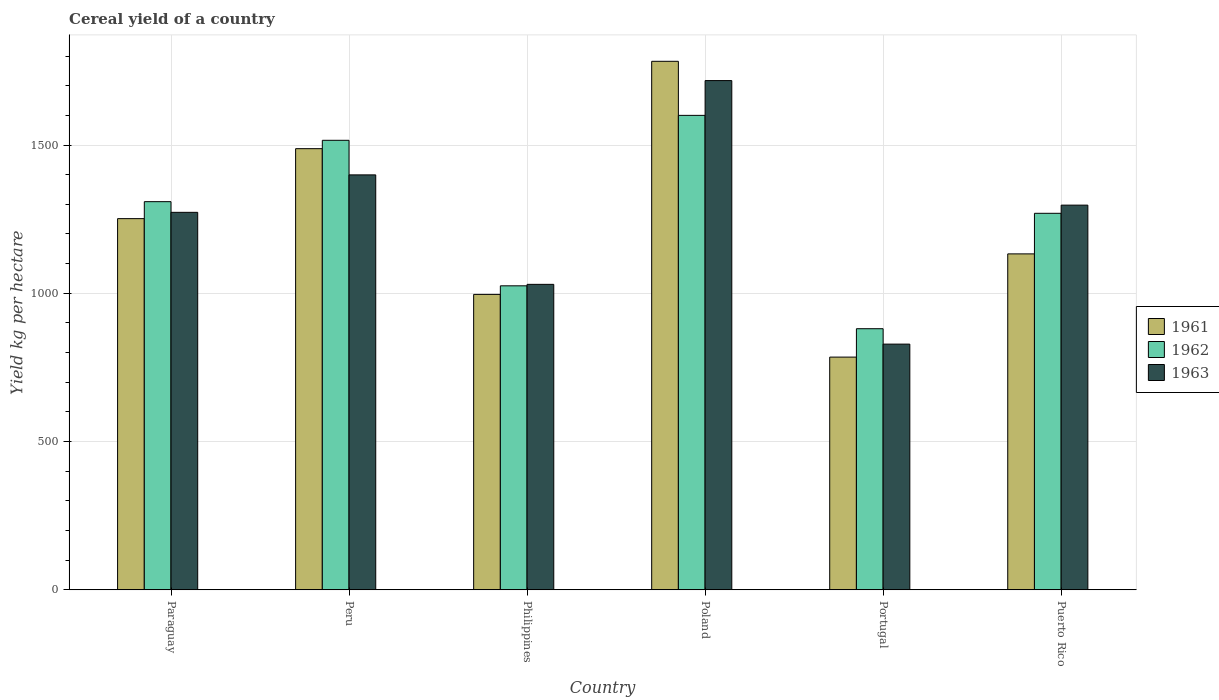How many different coloured bars are there?
Make the answer very short. 3. How many groups of bars are there?
Your response must be concise. 6. Are the number of bars per tick equal to the number of legend labels?
Provide a short and direct response. Yes. Are the number of bars on each tick of the X-axis equal?
Ensure brevity in your answer.  Yes. How many bars are there on the 1st tick from the left?
Offer a terse response. 3. What is the label of the 1st group of bars from the left?
Offer a terse response. Paraguay. In how many cases, is the number of bars for a given country not equal to the number of legend labels?
Make the answer very short. 0. What is the total cereal yield in 1961 in Paraguay?
Your answer should be compact. 1251.79. Across all countries, what is the maximum total cereal yield in 1963?
Offer a very short reply. 1717.34. Across all countries, what is the minimum total cereal yield in 1961?
Give a very brief answer. 784.84. In which country was the total cereal yield in 1962 minimum?
Your answer should be very brief. Portugal. What is the total total cereal yield in 1963 in the graph?
Offer a terse response. 7545.87. What is the difference between the total cereal yield in 1963 in Paraguay and that in Poland?
Your answer should be compact. -444.3. What is the difference between the total cereal yield in 1962 in Puerto Rico and the total cereal yield in 1961 in Poland?
Your answer should be compact. -512.57. What is the average total cereal yield in 1961 per country?
Offer a very short reply. 1239.33. What is the difference between the total cereal yield of/in 1961 and total cereal yield of/in 1962 in Portugal?
Offer a very short reply. -95.75. In how many countries, is the total cereal yield in 1961 greater than 1700 kg per hectare?
Make the answer very short. 1. What is the ratio of the total cereal yield in 1963 in Philippines to that in Poland?
Offer a terse response. 0.6. Is the total cereal yield in 1961 in Philippines less than that in Puerto Rico?
Your answer should be very brief. Yes. What is the difference between the highest and the second highest total cereal yield in 1962?
Offer a very short reply. 84.11. What is the difference between the highest and the lowest total cereal yield in 1962?
Make the answer very short. 719.47. In how many countries, is the total cereal yield in 1961 greater than the average total cereal yield in 1961 taken over all countries?
Your answer should be very brief. 3. Are all the bars in the graph horizontal?
Your response must be concise. No. How many countries are there in the graph?
Ensure brevity in your answer.  6. Are the values on the major ticks of Y-axis written in scientific E-notation?
Keep it short and to the point. No. Does the graph contain grids?
Offer a very short reply. Yes. How many legend labels are there?
Your response must be concise. 3. How are the legend labels stacked?
Your answer should be very brief. Vertical. What is the title of the graph?
Offer a very short reply. Cereal yield of a country. Does "2001" appear as one of the legend labels in the graph?
Your answer should be very brief. No. What is the label or title of the X-axis?
Make the answer very short. Country. What is the label or title of the Y-axis?
Your response must be concise. Yield kg per hectare. What is the Yield kg per hectare in 1961 in Paraguay?
Ensure brevity in your answer.  1251.79. What is the Yield kg per hectare of 1962 in Paraguay?
Your answer should be very brief. 1309.03. What is the Yield kg per hectare of 1963 in Paraguay?
Give a very brief answer. 1273.04. What is the Yield kg per hectare in 1961 in Peru?
Keep it short and to the point. 1487.76. What is the Yield kg per hectare in 1962 in Peru?
Provide a succinct answer. 1515.95. What is the Yield kg per hectare of 1963 in Peru?
Your response must be concise. 1399.36. What is the Yield kg per hectare in 1961 in Philippines?
Make the answer very short. 996.33. What is the Yield kg per hectare in 1962 in Philippines?
Keep it short and to the point. 1025.25. What is the Yield kg per hectare of 1963 in Philippines?
Give a very brief answer. 1030.2. What is the Yield kg per hectare of 1961 in Poland?
Your response must be concise. 1782.35. What is the Yield kg per hectare of 1962 in Poland?
Ensure brevity in your answer.  1600.06. What is the Yield kg per hectare of 1963 in Poland?
Offer a very short reply. 1717.34. What is the Yield kg per hectare of 1961 in Portugal?
Your answer should be compact. 784.84. What is the Yield kg per hectare in 1962 in Portugal?
Offer a terse response. 880.59. What is the Yield kg per hectare in 1963 in Portugal?
Provide a short and direct response. 828.63. What is the Yield kg per hectare in 1961 in Puerto Rico?
Offer a very short reply. 1132.94. What is the Yield kg per hectare of 1962 in Puerto Rico?
Provide a short and direct response. 1269.79. What is the Yield kg per hectare in 1963 in Puerto Rico?
Ensure brevity in your answer.  1297.3. Across all countries, what is the maximum Yield kg per hectare in 1961?
Offer a terse response. 1782.35. Across all countries, what is the maximum Yield kg per hectare in 1962?
Ensure brevity in your answer.  1600.06. Across all countries, what is the maximum Yield kg per hectare in 1963?
Your answer should be very brief. 1717.34. Across all countries, what is the minimum Yield kg per hectare in 1961?
Your answer should be compact. 784.84. Across all countries, what is the minimum Yield kg per hectare in 1962?
Offer a very short reply. 880.59. Across all countries, what is the minimum Yield kg per hectare in 1963?
Your answer should be very brief. 828.63. What is the total Yield kg per hectare of 1961 in the graph?
Keep it short and to the point. 7436. What is the total Yield kg per hectare of 1962 in the graph?
Offer a very short reply. 7600.67. What is the total Yield kg per hectare of 1963 in the graph?
Your response must be concise. 7545.87. What is the difference between the Yield kg per hectare in 1961 in Paraguay and that in Peru?
Keep it short and to the point. -235.96. What is the difference between the Yield kg per hectare in 1962 in Paraguay and that in Peru?
Offer a very short reply. -206.92. What is the difference between the Yield kg per hectare of 1963 in Paraguay and that in Peru?
Your answer should be compact. -126.32. What is the difference between the Yield kg per hectare of 1961 in Paraguay and that in Philippines?
Your answer should be very brief. 255.47. What is the difference between the Yield kg per hectare in 1962 in Paraguay and that in Philippines?
Your answer should be compact. 283.78. What is the difference between the Yield kg per hectare of 1963 in Paraguay and that in Philippines?
Make the answer very short. 242.84. What is the difference between the Yield kg per hectare in 1961 in Paraguay and that in Poland?
Offer a terse response. -530.56. What is the difference between the Yield kg per hectare in 1962 in Paraguay and that in Poland?
Make the answer very short. -291.03. What is the difference between the Yield kg per hectare in 1963 in Paraguay and that in Poland?
Your answer should be compact. -444.3. What is the difference between the Yield kg per hectare in 1961 in Paraguay and that in Portugal?
Give a very brief answer. 466.96. What is the difference between the Yield kg per hectare in 1962 in Paraguay and that in Portugal?
Offer a terse response. 428.44. What is the difference between the Yield kg per hectare of 1963 in Paraguay and that in Portugal?
Keep it short and to the point. 444.4. What is the difference between the Yield kg per hectare in 1961 in Paraguay and that in Puerto Rico?
Provide a short and direct response. 118.85. What is the difference between the Yield kg per hectare in 1962 in Paraguay and that in Puerto Rico?
Offer a terse response. 39.24. What is the difference between the Yield kg per hectare of 1963 in Paraguay and that in Puerto Rico?
Give a very brief answer. -24.26. What is the difference between the Yield kg per hectare in 1961 in Peru and that in Philippines?
Provide a succinct answer. 491.43. What is the difference between the Yield kg per hectare in 1962 in Peru and that in Philippines?
Your answer should be compact. 490.7. What is the difference between the Yield kg per hectare of 1963 in Peru and that in Philippines?
Provide a short and direct response. 369.16. What is the difference between the Yield kg per hectare in 1961 in Peru and that in Poland?
Your answer should be very brief. -294.6. What is the difference between the Yield kg per hectare of 1962 in Peru and that in Poland?
Give a very brief answer. -84.11. What is the difference between the Yield kg per hectare in 1963 in Peru and that in Poland?
Make the answer very short. -317.98. What is the difference between the Yield kg per hectare in 1961 in Peru and that in Portugal?
Your answer should be compact. 702.92. What is the difference between the Yield kg per hectare of 1962 in Peru and that in Portugal?
Offer a very short reply. 635.36. What is the difference between the Yield kg per hectare in 1963 in Peru and that in Portugal?
Keep it short and to the point. 570.73. What is the difference between the Yield kg per hectare of 1961 in Peru and that in Puerto Rico?
Offer a very short reply. 354.82. What is the difference between the Yield kg per hectare in 1962 in Peru and that in Puerto Rico?
Your response must be concise. 246.17. What is the difference between the Yield kg per hectare of 1963 in Peru and that in Puerto Rico?
Ensure brevity in your answer.  102.06. What is the difference between the Yield kg per hectare in 1961 in Philippines and that in Poland?
Give a very brief answer. -786.03. What is the difference between the Yield kg per hectare of 1962 in Philippines and that in Poland?
Provide a succinct answer. -574.81. What is the difference between the Yield kg per hectare in 1963 in Philippines and that in Poland?
Offer a terse response. -687.14. What is the difference between the Yield kg per hectare in 1961 in Philippines and that in Portugal?
Offer a very short reply. 211.49. What is the difference between the Yield kg per hectare of 1962 in Philippines and that in Portugal?
Give a very brief answer. 144.66. What is the difference between the Yield kg per hectare of 1963 in Philippines and that in Portugal?
Provide a succinct answer. 201.56. What is the difference between the Yield kg per hectare in 1961 in Philippines and that in Puerto Rico?
Offer a very short reply. -136.61. What is the difference between the Yield kg per hectare of 1962 in Philippines and that in Puerto Rico?
Keep it short and to the point. -244.53. What is the difference between the Yield kg per hectare of 1963 in Philippines and that in Puerto Rico?
Give a very brief answer. -267.1. What is the difference between the Yield kg per hectare in 1961 in Poland and that in Portugal?
Provide a short and direct response. 997.52. What is the difference between the Yield kg per hectare of 1962 in Poland and that in Portugal?
Give a very brief answer. 719.47. What is the difference between the Yield kg per hectare of 1963 in Poland and that in Portugal?
Provide a short and direct response. 888.7. What is the difference between the Yield kg per hectare of 1961 in Poland and that in Puerto Rico?
Your answer should be very brief. 649.41. What is the difference between the Yield kg per hectare in 1962 in Poland and that in Puerto Rico?
Offer a very short reply. 330.27. What is the difference between the Yield kg per hectare of 1963 in Poland and that in Puerto Rico?
Offer a very short reply. 420.04. What is the difference between the Yield kg per hectare in 1961 in Portugal and that in Puerto Rico?
Your response must be concise. -348.1. What is the difference between the Yield kg per hectare of 1962 in Portugal and that in Puerto Rico?
Provide a succinct answer. -389.2. What is the difference between the Yield kg per hectare of 1963 in Portugal and that in Puerto Rico?
Keep it short and to the point. -468.67. What is the difference between the Yield kg per hectare of 1961 in Paraguay and the Yield kg per hectare of 1962 in Peru?
Make the answer very short. -264.16. What is the difference between the Yield kg per hectare of 1961 in Paraguay and the Yield kg per hectare of 1963 in Peru?
Give a very brief answer. -147.57. What is the difference between the Yield kg per hectare in 1962 in Paraguay and the Yield kg per hectare in 1963 in Peru?
Provide a short and direct response. -90.33. What is the difference between the Yield kg per hectare in 1961 in Paraguay and the Yield kg per hectare in 1962 in Philippines?
Offer a very short reply. 226.54. What is the difference between the Yield kg per hectare in 1961 in Paraguay and the Yield kg per hectare in 1963 in Philippines?
Your answer should be very brief. 221.59. What is the difference between the Yield kg per hectare of 1962 in Paraguay and the Yield kg per hectare of 1963 in Philippines?
Make the answer very short. 278.83. What is the difference between the Yield kg per hectare in 1961 in Paraguay and the Yield kg per hectare in 1962 in Poland?
Offer a very short reply. -348.27. What is the difference between the Yield kg per hectare in 1961 in Paraguay and the Yield kg per hectare in 1963 in Poland?
Keep it short and to the point. -465.55. What is the difference between the Yield kg per hectare in 1962 in Paraguay and the Yield kg per hectare in 1963 in Poland?
Ensure brevity in your answer.  -408.31. What is the difference between the Yield kg per hectare of 1961 in Paraguay and the Yield kg per hectare of 1962 in Portugal?
Offer a very short reply. 371.2. What is the difference between the Yield kg per hectare of 1961 in Paraguay and the Yield kg per hectare of 1963 in Portugal?
Make the answer very short. 423.16. What is the difference between the Yield kg per hectare in 1962 in Paraguay and the Yield kg per hectare in 1963 in Portugal?
Make the answer very short. 480.39. What is the difference between the Yield kg per hectare of 1961 in Paraguay and the Yield kg per hectare of 1962 in Puerto Rico?
Provide a short and direct response. -17.99. What is the difference between the Yield kg per hectare of 1961 in Paraguay and the Yield kg per hectare of 1963 in Puerto Rico?
Offer a very short reply. -45.51. What is the difference between the Yield kg per hectare of 1962 in Paraguay and the Yield kg per hectare of 1963 in Puerto Rico?
Make the answer very short. 11.73. What is the difference between the Yield kg per hectare of 1961 in Peru and the Yield kg per hectare of 1962 in Philippines?
Your answer should be very brief. 462.5. What is the difference between the Yield kg per hectare of 1961 in Peru and the Yield kg per hectare of 1963 in Philippines?
Ensure brevity in your answer.  457.56. What is the difference between the Yield kg per hectare in 1962 in Peru and the Yield kg per hectare in 1963 in Philippines?
Ensure brevity in your answer.  485.75. What is the difference between the Yield kg per hectare in 1961 in Peru and the Yield kg per hectare in 1962 in Poland?
Your answer should be compact. -112.3. What is the difference between the Yield kg per hectare in 1961 in Peru and the Yield kg per hectare in 1963 in Poland?
Make the answer very short. -229.58. What is the difference between the Yield kg per hectare of 1962 in Peru and the Yield kg per hectare of 1963 in Poland?
Offer a terse response. -201.38. What is the difference between the Yield kg per hectare of 1961 in Peru and the Yield kg per hectare of 1962 in Portugal?
Your answer should be very brief. 607.17. What is the difference between the Yield kg per hectare of 1961 in Peru and the Yield kg per hectare of 1963 in Portugal?
Ensure brevity in your answer.  659.12. What is the difference between the Yield kg per hectare in 1962 in Peru and the Yield kg per hectare in 1963 in Portugal?
Your response must be concise. 687.32. What is the difference between the Yield kg per hectare in 1961 in Peru and the Yield kg per hectare in 1962 in Puerto Rico?
Offer a terse response. 217.97. What is the difference between the Yield kg per hectare in 1961 in Peru and the Yield kg per hectare in 1963 in Puerto Rico?
Make the answer very short. 190.46. What is the difference between the Yield kg per hectare of 1962 in Peru and the Yield kg per hectare of 1963 in Puerto Rico?
Ensure brevity in your answer.  218.65. What is the difference between the Yield kg per hectare in 1961 in Philippines and the Yield kg per hectare in 1962 in Poland?
Provide a short and direct response. -603.73. What is the difference between the Yield kg per hectare in 1961 in Philippines and the Yield kg per hectare in 1963 in Poland?
Offer a terse response. -721.01. What is the difference between the Yield kg per hectare of 1962 in Philippines and the Yield kg per hectare of 1963 in Poland?
Your answer should be compact. -692.09. What is the difference between the Yield kg per hectare in 1961 in Philippines and the Yield kg per hectare in 1962 in Portugal?
Offer a very short reply. 115.74. What is the difference between the Yield kg per hectare of 1961 in Philippines and the Yield kg per hectare of 1963 in Portugal?
Provide a succinct answer. 167.69. What is the difference between the Yield kg per hectare in 1962 in Philippines and the Yield kg per hectare in 1963 in Portugal?
Your answer should be very brief. 196.62. What is the difference between the Yield kg per hectare of 1961 in Philippines and the Yield kg per hectare of 1962 in Puerto Rico?
Provide a succinct answer. -273.46. What is the difference between the Yield kg per hectare of 1961 in Philippines and the Yield kg per hectare of 1963 in Puerto Rico?
Ensure brevity in your answer.  -300.97. What is the difference between the Yield kg per hectare of 1962 in Philippines and the Yield kg per hectare of 1963 in Puerto Rico?
Your answer should be compact. -272.05. What is the difference between the Yield kg per hectare of 1961 in Poland and the Yield kg per hectare of 1962 in Portugal?
Offer a terse response. 901.76. What is the difference between the Yield kg per hectare of 1961 in Poland and the Yield kg per hectare of 1963 in Portugal?
Your answer should be very brief. 953.72. What is the difference between the Yield kg per hectare in 1962 in Poland and the Yield kg per hectare in 1963 in Portugal?
Offer a terse response. 771.42. What is the difference between the Yield kg per hectare in 1961 in Poland and the Yield kg per hectare in 1962 in Puerto Rico?
Make the answer very short. 512.57. What is the difference between the Yield kg per hectare of 1961 in Poland and the Yield kg per hectare of 1963 in Puerto Rico?
Provide a short and direct response. 485.05. What is the difference between the Yield kg per hectare in 1962 in Poland and the Yield kg per hectare in 1963 in Puerto Rico?
Offer a very short reply. 302.76. What is the difference between the Yield kg per hectare of 1961 in Portugal and the Yield kg per hectare of 1962 in Puerto Rico?
Keep it short and to the point. -484.95. What is the difference between the Yield kg per hectare in 1961 in Portugal and the Yield kg per hectare in 1963 in Puerto Rico?
Your response must be concise. -512.46. What is the difference between the Yield kg per hectare of 1962 in Portugal and the Yield kg per hectare of 1963 in Puerto Rico?
Ensure brevity in your answer.  -416.71. What is the average Yield kg per hectare in 1961 per country?
Your answer should be very brief. 1239.33. What is the average Yield kg per hectare in 1962 per country?
Your answer should be very brief. 1266.78. What is the average Yield kg per hectare in 1963 per country?
Ensure brevity in your answer.  1257.65. What is the difference between the Yield kg per hectare in 1961 and Yield kg per hectare in 1962 in Paraguay?
Your answer should be very brief. -57.24. What is the difference between the Yield kg per hectare in 1961 and Yield kg per hectare in 1963 in Paraguay?
Your response must be concise. -21.25. What is the difference between the Yield kg per hectare in 1962 and Yield kg per hectare in 1963 in Paraguay?
Your answer should be compact. 35.99. What is the difference between the Yield kg per hectare of 1961 and Yield kg per hectare of 1962 in Peru?
Give a very brief answer. -28.2. What is the difference between the Yield kg per hectare of 1961 and Yield kg per hectare of 1963 in Peru?
Your response must be concise. 88.39. What is the difference between the Yield kg per hectare in 1962 and Yield kg per hectare in 1963 in Peru?
Your answer should be very brief. 116.59. What is the difference between the Yield kg per hectare in 1961 and Yield kg per hectare in 1962 in Philippines?
Your answer should be very brief. -28.93. What is the difference between the Yield kg per hectare of 1961 and Yield kg per hectare of 1963 in Philippines?
Your answer should be very brief. -33.87. What is the difference between the Yield kg per hectare in 1962 and Yield kg per hectare in 1963 in Philippines?
Your answer should be very brief. -4.95. What is the difference between the Yield kg per hectare of 1961 and Yield kg per hectare of 1962 in Poland?
Keep it short and to the point. 182.29. What is the difference between the Yield kg per hectare in 1961 and Yield kg per hectare in 1963 in Poland?
Provide a short and direct response. 65.02. What is the difference between the Yield kg per hectare in 1962 and Yield kg per hectare in 1963 in Poland?
Offer a very short reply. -117.28. What is the difference between the Yield kg per hectare of 1961 and Yield kg per hectare of 1962 in Portugal?
Provide a short and direct response. -95.75. What is the difference between the Yield kg per hectare of 1961 and Yield kg per hectare of 1963 in Portugal?
Provide a succinct answer. -43.8. What is the difference between the Yield kg per hectare of 1962 and Yield kg per hectare of 1963 in Portugal?
Offer a very short reply. 51.95. What is the difference between the Yield kg per hectare in 1961 and Yield kg per hectare in 1962 in Puerto Rico?
Offer a terse response. -136.85. What is the difference between the Yield kg per hectare in 1961 and Yield kg per hectare in 1963 in Puerto Rico?
Provide a short and direct response. -164.36. What is the difference between the Yield kg per hectare in 1962 and Yield kg per hectare in 1963 in Puerto Rico?
Offer a very short reply. -27.51. What is the ratio of the Yield kg per hectare of 1961 in Paraguay to that in Peru?
Provide a short and direct response. 0.84. What is the ratio of the Yield kg per hectare in 1962 in Paraguay to that in Peru?
Your response must be concise. 0.86. What is the ratio of the Yield kg per hectare in 1963 in Paraguay to that in Peru?
Make the answer very short. 0.91. What is the ratio of the Yield kg per hectare of 1961 in Paraguay to that in Philippines?
Ensure brevity in your answer.  1.26. What is the ratio of the Yield kg per hectare in 1962 in Paraguay to that in Philippines?
Keep it short and to the point. 1.28. What is the ratio of the Yield kg per hectare in 1963 in Paraguay to that in Philippines?
Provide a succinct answer. 1.24. What is the ratio of the Yield kg per hectare of 1961 in Paraguay to that in Poland?
Make the answer very short. 0.7. What is the ratio of the Yield kg per hectare of 1962 in Paraguay to that in Poland?
Your response must be concise. 0.82. What is the ratio of the Yield kg per hectare of 1963 in Paraguay to that in Poland?
Provide a short and direct response. 0.74. What is the ratio of the Yield kg per hectare of 1961 in Paraguay to that in Portugal?
Ensure brevity in your answer.  1.59. What is the ratio of the Yield kg per hectare in 1962 in Paraguay to that in Portugal?
Keep it short and to the point. 1.49. What is the ratio of the Yield kg per hectare of 1963 in Paraguay to that in Portugal?
Provide a succinct answer. 1.54. What is the ratio of the Yield kg per hectare of 1961 in Paraguay to that in Puerto Rico?
Keep it short and to the point. 1.1. What is the ratio of the Yield kg per hectare in 1962 in Paraguay to that in Puerto Rico?
Offer a terse response. 1.03. What is the ratio of the Yield kg per hectare of 1963 in Paraguay to that in Puerto Rico?
Offer a very short reply. 0.98. What is the ratio of the Yield kg per hectare of 1961 in Peru to that in Philippines?
Provide a short and direct response. 1.49. What is the ratio of the Yield kg per hectare of 1962 in Peru to that in Philippines?
Make the answer very short. 1.48. What is the ratio of the Yield kg per hectare of 1963 in Peru to that in Philippines?
Provide a short and direct response. 1.36. What is the ratio of the Yield kg per hectare of 1961 in Peru to that in Poland?
Give a very brief answer. 0.83. What is the ratio of the Yield kg per hectare in 1962 in Peru to that in Poland?
Your response must be concise. 0.95. What is the ratio of the Yield kg per hectare in 1963 in Peru to that in Poland?
Give a very brief answer. 0.81. What is the ratio of the Yield kg per hectare in 1961 in Peru to that in Portugal?
Your response must be concise. 1.9. What is the ratio of the Yield kg per hectare of 1962 in Peru to that in Portugal?
Provide a succinct answer. 1.72. What is the ratio of the Yield kg per hectare of 1963 in Peru to that in Portugal?
Offer a very short reply. 1.69. What is the ratio of the Yield kg per hectare of 1961 in Peru to that in Puerto Rico?
Your response must be concise. 1.31. What is the ratio of the Yield kg per hectare of 1962 in Peru to that in Puerto Rico?
Provide a short and direct response. 1.19. What is the ratio of the Yield kg per hectare in 1963 in Peru to that in Puerto Rico?
Make the answer very short. 1.08. What is the ratio of the Yield kg per hectare in 1961 in Philippines to that in Poland?
Make the answer very short. 0.56. What is the ratio of the Yield kg per hectare in 1962 in Philippines to that in Poland?
Keep it short and to the point. 0.64. What is the ratio of the Yield kg per hectare of 1963 in Philippines to that in Poland?
Make the answer very short. 0.6. What is the ratio of the Yield kg per hectare of 1961 in Philippines to that in Portugal?
Give a very brief answer. 1.27. What is the ratio of the Yield kg per hectare in 1962 in Philippines to that in Portugal?
Keep it short and to the point. 1.16. What is the ratio of the Yield kg per hectare of 1963 in Philippines to that in Portugal?
Offer a very short reply. 1.24. What is the ratio of the Yield kg per hectare of 1961 in Philippines to that in Puerto Rico?
Give a very brief answer. 0.88. What is the ratio of the Yield kg per hectare of 1962 in Philippines to that in Puerto Rico?
Make the answer very short. 0.81. What is the ratio of the Yield kg per hectare of 1963 in Philippines to that in Puerto Rico?
Your answer should be very brief. 0.79. What is the ratio of the Yield kg per hectare in 1961 in Poland to that in Portugal?
Your answer should be compact. 2.27. What is the ratio of the Yield kg per hectare in 1962 in Poland to that in Portugal?
Provide a succinct answer. 1.82. What is the ratio of the Yield kg per hectare in 1963 in Poland to that in Portugal?
Your response must be concise. 2.07. What is the ratio of the Yield kg per hectare in 1961 in Poland to that in Puerto Rico?
Provide a short and direct response. 1.57. What is the ratio of the Yield kg per hectare in 1962 in Poland to that in Puerto Rico?
Keep it short and to the point. 1.26. What is the ratio of the Yield kg per hectare of 1963 in Poland to that in Puerto Rico?
Your answer should be compact. 1.32. What is the ratio of the Yield kg per hectare of 1961 in Portugal to that in Puerto Rico?
Offer a terse response. 0.69. What is the ratio of the Yield kg per hectare of 1962 in Portugal to that in Puerto Rico?
Ensure brevity in your answer.  0.69. What is the ratio of the Yield kg per hectare of 1963 in Portugal to that in Puerto Rico?
Make the answer very short. 0.64. What is the difference between the highest and the second highest Yield kg per hectare of 1961?
Offer a very short reply. 294.6. What is the difference between the highest and the second highest Yield kg per hectare of 1962?
Provide a succinct answer. 84.11. What is the difference between the highest and the second highest Yield kg per hectare of 1963?
Keep it short and to the point. 317.98. What is the difference between the highest and the lowest Yield kg per hectare of 1961?
Offer a terse response. 997.52. What is the difference between the highest and the lowest Yield kg per hectare in 1962?
Ensure brevity in your answer.  719.47. What is the difference between the highest and the lowest Yield kg per hectare of 1963?
Make the answer very short. 888.7. 